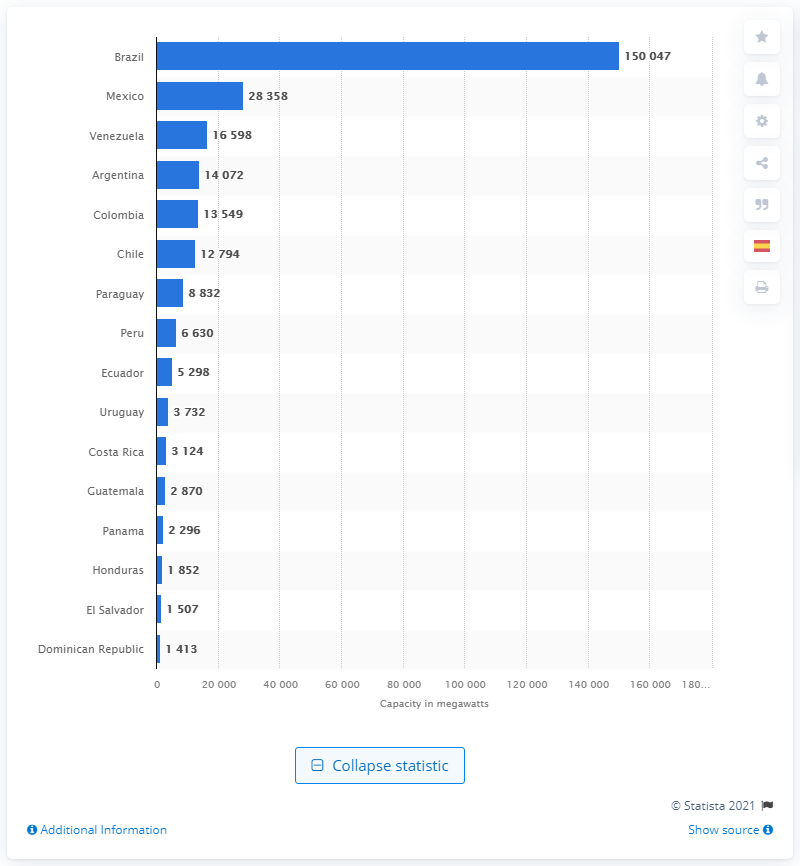Point out several critical features in this image. Brazil was the leading Latin American country in terms of installed renewable energy capacity in 2020. 